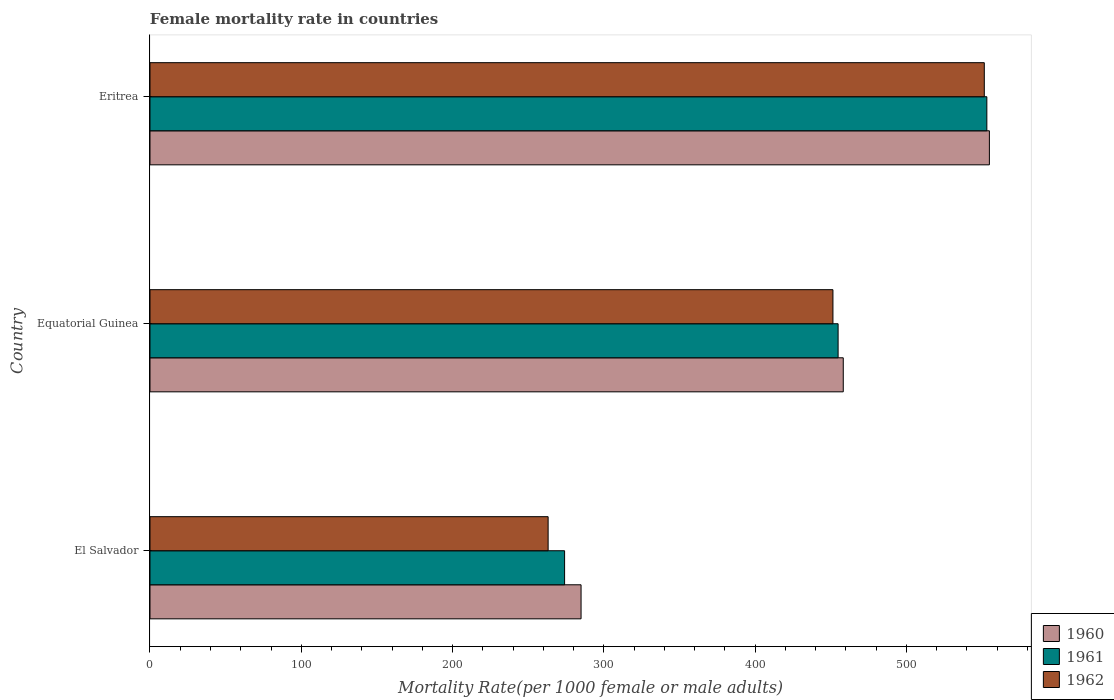How many different coloured bars are there?
Your answer should be very brief. 3. How many bars are there on the 2nd tick from the bottom?
Keep it short and to the point. 3. What is the label of the 1st group of bars from the top?
Provide a succinct answer. Eritrea. What is the female mortality rate in 1960 in El Salvador?
Make the answer very short. 284.94. Across all countries, what is the maximum female mortality rate in 1962?
Provide a short and direct response. 551.48. Across all countries, what is the minimum female mortality rate in 1961?
Your response must be concise. 274.05. In which country was the female mortality rate in 1961 maximum?
Keep it short and to the point. Eritrea. In which country was the female mortality rate in 1962 minimum?
Keep it short and to the point. El Salvador. What is the total female mortality rate in 1960 in the graph?
Your answer should be compact. 1298.04. What is the difference between the female mortality rate in 1960 in El Salvador and that in Equatorial Guinea?
Ensure brevity in your answer.  -173.32. What is the difference between the female mortality rate in 1961 in El Salvador and the female mortality rate in 1960 in Eritrea?
Provide a succinct answer. -280.8. What is the average female mortality rate in 1960 per country?
Your response must be concise. 432.68. What is the difference between the female mortality rate in 1962 and female mortality rate in 1961 in Eritrea?
Give a very brief answer. -1.69. What is the ratio of the female mortality rate in 1960 in Equatorial Guinea to that in Eritrea?
Give a very brief answer. 0.83. What is the difference between the highest and the second highest female mortality rate in 1962?
Offer a very short reply. 100.05. What is the difference between the highest and the lowest female mortality rate in 1962?
Your answer should be very brief. 288.31. In how many countries, is the female mortality rate in 1961 greater than the average female mortality rate in 1961 taken over all countries?
Your answer should be very brief. 2. Is the sum of the female mortality rate in 1960 in Equatorial Guinea and Eritrea greater than the maximum female mortality rate in 1962 across all countries?
Give a very brief answer. Yes. What does the 3rd bar from the top in El Salvador represents?
Give a very brief answer. 1960. What does the 2nd bar from the bottom in El Salvador represents?
Keep it short and to the point. 1961. Is it the case that in every country, the sum of the female mortality rate in 1960 and female mortality rate in 1962 is greater than the female mortality rate in 1961?
Give a very brief answer. Yes. How many bars are there?
Your answer should be compact. 9. How many countries are there in the graph?
Offer a terse response. 3. What is the difference between two consecutive major ticks on the X-axis?
Your response must be concise. 100. Does the graph contain any zero values?
Your response must be concise. No. Does the graph contain grids?
Ensure brevity in your answer.  No. Where does the legend appear in the graph?
Offer a terse response. Bottom right. How many legend labels are there?
Offer a terse response. 3. What is the title of the graph?
Your answer should be compact. Female mortality rate in countries. What is the label or title of the X-axis?
Provide a short and direct response. Mortality Rate(per 1000 female or male adults). What is the Mortality Rate(per 1000 female or male adults) of 1960 in El Salvador?
Keep it short and to the point. 284.94. What is the Mortality Rate(per 1000 female or male adults) in 1961 in El Salvador?
Offer a very short reply. 274.05. What is the Mortality Rate(per 1000 female or male adults) in 1962 in El Salvador?
Make the answer very short. 263.17. What is the Mortality Rate(per 1000 female or male adults) in 1960 in Equatorial Guinea?
Ensure brevity in your answer.  458.26. What is the Mortality Rate(per 1000 female or male adults) of 1961 in Equatorial Guinea?
Give a very brief answer. 454.84. What is the Mortality Rate(per 1000 female or male adults) of 1962 in Equatorial Guinea?
Your answer should be very brief. 451.43. What is the Mortality Rate(per 1000 female or male adults) in 1960 in Eritrea?
Ensure brevity in your answer.  554.85. What is the Mortality Rate(per 1000 female or male adults) of 1961 in Eritrea?
Your answer should be compact. 553.16. What is the Mortality Rate(per 1000 female or male adults) in 1962 in Eritrea?
Ensure brevity in your answer.  551.48. Across all countries, what is the maximum Mortality Rate(per 1000 female or male adults) of 1960?
Provide a succinct answer. 554.85. Across all countries, what is the maximum Mortality Rate(per 1000 female or male adults) of 1961?
Your answer should be compact. 553.16. Across all countries, what is the maximum Mortality Rate(per 1000 female or male adults) in 1962?
Offer a terse response. 551.48. Across all countries, what is the minimum Mortality Rate(per 1000 female or male adults) in 1960?
Your answer should be compact. 284.94. Across all countries, what is the minimum Mortality Rate(per 1000 female or male adults) of 1961?
Provide a short and direct response. 274.05. Across all countries, what is the minimum Mortality Rate(per 1000 female or male adults) of 1962?
Offer a terse response. 263.17. What is the total Mortality Rate(per 1000 female or male adults) of 1960 in the graph?
Ensure brevity in your answer.  1298.04. What is the total Mortality Rate(per 1000 female or male adults) of 1961 in the graph?
Provide a short and direct response. 1282.06. What is the total Mortality Rate(per 1000 female or male adults) of 1962 in the graph?
Offer a terse response. 1266.08. What is the difference between the Mortality Rate(per 1000 female or male adults) of 1960 in El Salvador and that in Equatorial Guinea?
Your response must be concise. -173.32. What is the difference between the Mortality Rate(per 1000 female or male adults) in 1961 in El Salvador and that in Equatorial Guinea?
Make the answer very short. -180.79. What is the difference between the Mortality Rate(per 1000 female or male adults) in 1962 in El Salvador and that in Equatorial Guinea?
Your response must be concise. -188.26. What is the difference between the Mortality Rate(per 1000 female or male adults) of 1960 in El Salvador and that in Eritrea?
Provide a short and direct response. -269.91. What is the difference between the Mortality Rate(per 1000 female or male adults) in 1961 in El Salvador and that in Eritrea?
Keep it short and to the point. -279.11. What is the difference between the Mortality Rate(per 1000 female or male adults) of 1962 in El Salvador and that in Eritrea?
Give a very brief answer. -288.31. What is the difference between the Mortality Rate(per 1000 female or male adults) in 1960 in Equatorial Guinea and that in Eritrea?
Provide a succinct answer. -96.59. What is the difference between the Mortality Rate(per 1000 female or male adults) in 1961 in Equatorial Guinea and that in Eritrea?
Provide a short and direct response. -98.32. What is the difference between the Mortality Rate(per 1000 female or male adults) of 1962 in Equatorial Guinea and that in Eritrea?
Provide a succinct answer. -100.05. What is the difference between the Mortality Rate(per 1000 female or male adults) of 1960 in El Salvador and the Mortality Rate(per 1000 female or male adults) of 1961 in Equatorial Guinea?
Your answer should be compact. -169.91. What is the difference between the Mortality Rate(per 1000 female or male adults) of 1960 in El Salvador and the Mortality Rate(per 1000 female or male adults) of 1962 in Equatorial Guinea?
Your answer should be very brief. -166.49. What is the difference between the Mortality Rate(per 1000 female or male adults) in 1961 in El Salvador and the Mortality Rate(per 1000 female or male adults) in 1962 in Equatorial Guinea?
Offer a very short reply. -177.38. What is the difference between the Mortality Rate(per 1000 female or male adults) in 1960 in El Salvador and the Mortality Rate(per 1000 female or male adults) in 1961 in Eritrea?
Offer a terse response. -268.23. What is the difference between the Mortality Rate(per 1000 female or male adults) of 1960 in El Salvador and the Mortality Rate(per 1000 female or male adults) of 1962 in Eritrea?
Ensure brevity in your answer.  -266.54. What is the difference between the Mortality Rate(per 1000 female or male adults) of 1961 in El Salvador and the Mortality Rate(per 1000 female or male adults) of 1962 in Eritrea?
Give a very brief answer. -277.42. What is the difference between the Mortality Rate(per 1000 female or male adults) in 1960 in Equatorial Guinea and the Mortality Rate(per 1000 female or male adults) in 1961 in Eritrea?
Your answer should be very brief. -94.91. What is the difference between the Mortality Rate(per 1000 female or male adults) of 1960 in Equatorial Guinea and the Mortality Rate(per 1000 female or male adults) of 1962 in Eritrea?
Provide a succinct answer. -93.22. What is the difference between the Mortality Rate(per 1000 female or male adults) in 1961 in Equatorial Guinea and the Mortality Rate(per 1000 female or male adults) in 1962 in Eritrea?
Your answer should be very brief. -96.63. What is the average Mortality Rate(per 1000 female or male adults) of 1960 per country?
Your answer should be compact. 432.68. What is the average Mortality Rate(per 1000 female or male adults) of 1961 per country?
Offer a terse response. 427.35. What is the average Mortality Rate(per 1000 female or male adults) of 1962 per country?
Make the answer very short. 422.03. What is the difference between the Mortality Rate(per 1000 female or male adults) of 1960 and Mortality Rate(per 1000 female or male adults) of 1961 in El Salvador?
Keep it short and to the point. 10.88. What is the difference between the Mortality Rate(per 1000 female or male adults) in 1960 and Mortality Rate(per 1000 female or male adults) in 1962 in El Salvador?
Offer a terse response. 21.77. What is the difference between the Mortality Rate(per 1000 female or male adults) of 1961 and Mortality Rate(per 1000 female or male adults) of 1962 in El Salvador?
Make the answer very short. 10.88. What is the difference between the Mortality Rate(per 1000 female or male adults) in 1960 and Mortality Rate(per 1000 female or male adults) in 1961 in Equatorial Guinea?
Your answer should be compact. 3.41. What is the difference between the Mortality Rate(per 1000 female or male adults) of 1960 and Mortality Rate(per 1000 female or male adults) of 1962 in Equatorial Guinea?
Give a very brief answer. 6.83. What is the difference between the Mortality Rate(per 1000 female or male adults) of 1961 and Mortality Rate(per 1000 female or male adults) of 1962 in Equatorial Guinea?
Offer a terse response. 3.41. What is the difference between the Mortality Rate(per 1000 female or male adults) of 1960 and Mortality Rate(per 1000 female or male adults) of 1961 in Eritrea?
Keep it short and to the point. 1.69. What is the difference between the Mortality Rate(per 1000 female or male adults) in 1960 and Mortality Rate(per 1000 female or male adults) in 1962 in Eritrea?
Your response must be concise. 3.37. What is the difference between the Mortality Rate(per 1000 female or male adults) in 1961 and Mortality Rate(per 1000 female or male adults) in 1962 in Eritrea?
Your answer should be very brief. 1.69. What is the ratio of the Mortality Rate(per 1000 female or male adults) of 1960 in El Salvador to that in Equatorial Guinea?
Make the answer very short. 0.62. What is the ratio of the Mortality Rate(per 1000 female or male adults) in 1961 in El Salvador to that in Equatorial Guinea?
Provide a succinct answer. 0.6. What is the ratio of the Mortality Rate(per 1000 female or male adults) of 1962 in El Salvador to that in Equatorial Guinea?
Make the answer very short. 0.58. What is the ratio of the Mortality Rate(per 1000 female or male adults) of 1960 in El Salvador to that in Eritrea?
Give a very brief answer. 0.51. What is the ratio of the Mortality Rate(per 1000 female or male adults) in 1961 in El Salvador to that in Eritrea?
Your answer should be compact. 0.5. What is the ratio of the Mortality Rate(per 1000 female or male adults) of 1962 in El Salvador to that in Eritrea?
Your response must be concise. 0.48. What is the ratio of the Mortality Rate(per 1000 female or male adults) in 1960 in Equatorial Guinea to that in Eritrea?
Offer a very short reply. 0.83. What is the ratio of the Mortality Rate(per 1000 female or male adults) of 1961 in Equatorial Guinea to that in Eritrea?
Your response must be concise. 0.82. What is the ratio of the Mortality Rate(per 1000 female or male adults) in 1962 in Equatorial Guinea to that in Eritrea?
Ensure brevity in your answer.  0.82. What is the difference between the highest and the second highest Mortality Rate(per 1000 female or male adults) of 1960?
Your answer should be very brief. 96.59. What is the difference between the highest and the second highest Mortality Rate(per 1000 female or male adults) of 1961?
Ensure brevity in your answer.  98.32. What is the difference between the highest and the second highest Mortality Rate(per 1000 female or male adults) in 1962?
Provide a succinct answer. 100.05. What is the difference between the highest and the lowest Mortality Rate(per 1000 female or male adults) in 1960?
Offer a very short reply. 269.91. What is the difference between the highest and the lowest Mortality Rate(per 1000 female or male adults) of 1961?
Your answer should be compact. 279.11. What is the difference between the highest and the lowest Mortality Rate(per 1000 female or male adults) of 1962?
Provide a short and direct response. 288.31. 